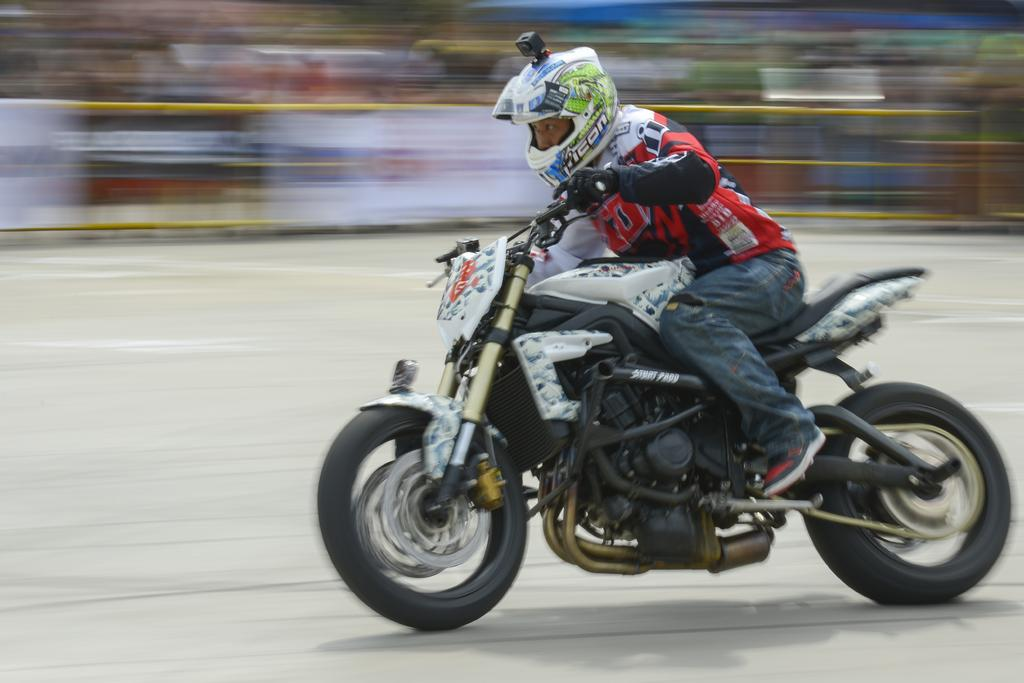What is the main subject of the image? There is a person riding a motorbike in the image. Where is the person riding the motorbike? The person is on the road. What is the person wearing while riding the motorbike? The person is wearing a dress with red, black, and blue colors. How is the background of the image depicted? The background of the image is blurred. What sense of fear can be observed in the person riding the motorbike? There is no indication of fear in the person riding the motorbike in the image. How many zippers are visible on the person's dress in the image? There is no mention of zippers on the person's dress in the image. 